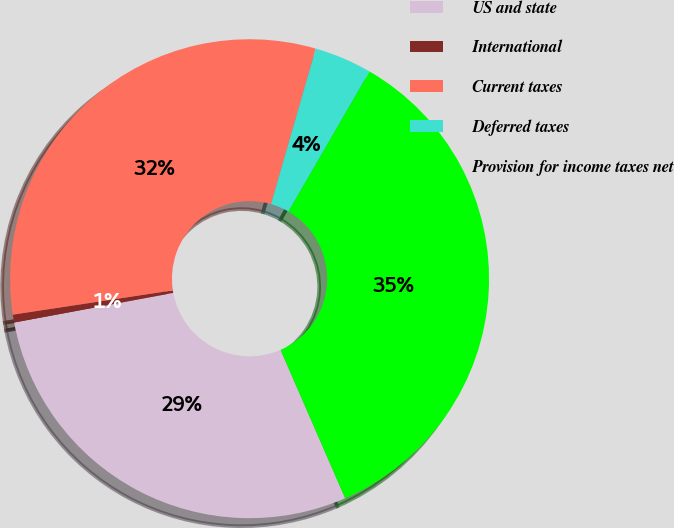<chart> <loc_0><loc_0><loc_500><loc_500><pie_chart><fcel>US and state<fcel>International<fcel>Current taxes<fcel>Deferred taxes<fcel>Provision for income taxes net<nl><fcel>28.61%<fcel>0.53%<fcel>31.86%<fcel>3.89%<fcel>35.11%<nl></chart> 